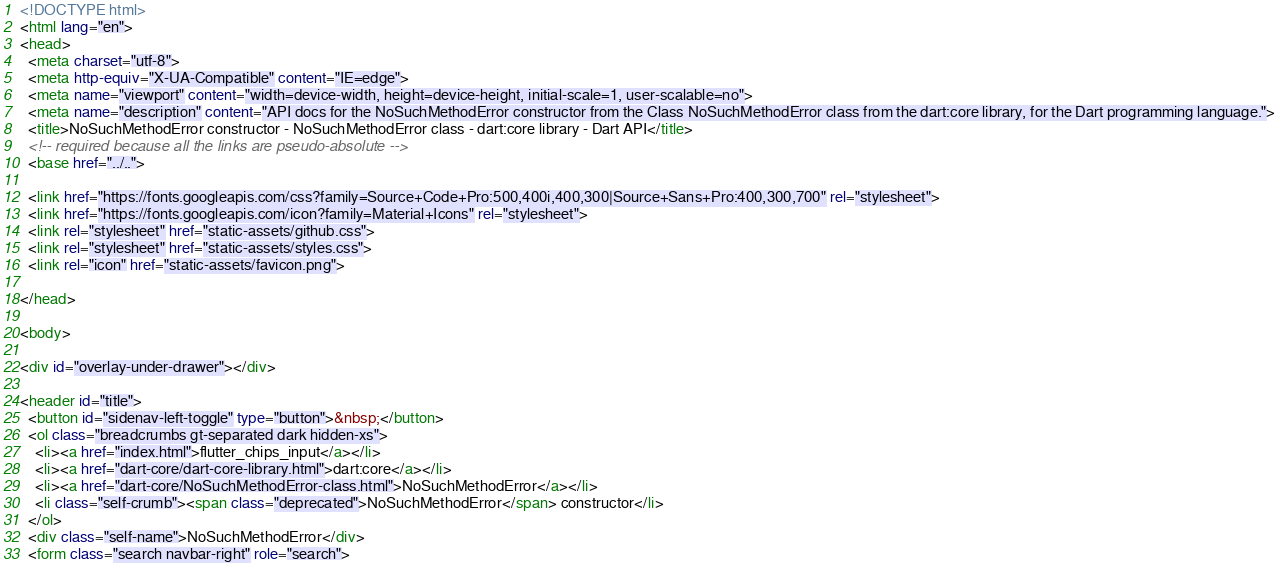Convert code to text. <code><loc_0><loc_0><loc_500><loc_500><_HTML_><!DOCTYPE html>
<html lang="en">
<head>
  <meta charset="utf-8">
  <meta http-equiv="X-UA-Compatible" content="IE=edge">
  <meta name="viewport" content="width=device-width, height=device-height, initial-scale=1, user-scalable=no">
  <meta name="description" content="API docs for the NoSuchMethodError constructor from the Class NoSuchMethodError class from the dart:core library, for the Dart programming language.">
  <title>NoSuchMethodError constructor - NoSuchMethodError class - dart:core library - Dart API</title>
  <!-- required because all the links are pseudo-absolute -->
  <base href="../..">

  <link href="https://fonts.googleapis.com/css?family=Source+Code+Pro:500,400i,400,300|Source+Sans+Pro:400,300,700" rel="stylesheet">
  <link href="https://fonts.googleapis.com/icon?family=Material+Icons" rel="stylesheet">
  <link rel="stylesheet" href="static-assets/github.css">
  <link rel="stylesheet" href="static-assets/styles.css">
  <link rel="icon" href="static-assets/favicon.png">
  
</head>

<body>

<div id="overlay-under-drawer"></div>

<header id="title">
  <button id="sidenav-left-toggle" type="button">&nbsp;</button>
  <ol class="breadcrumbs gt-separated dark hidden-xs">
    <li><a href="index.html">flutter_chips_input</a></li>
    <li><a href="dart-core/dart-core-library.html">dart:core</a></li>
    <li><a href="dart-core/NoSuchMethodError-class.html">NoSuchMethodError</a></li>
    <li class="self-crumb"><span class="deprecated">NoSuchMethodError</span> constructor</li>
  </ol>
  <div class="self-name">NoSuchMethodError</div>
  <form class="search navbar-right" role="search"></code> 